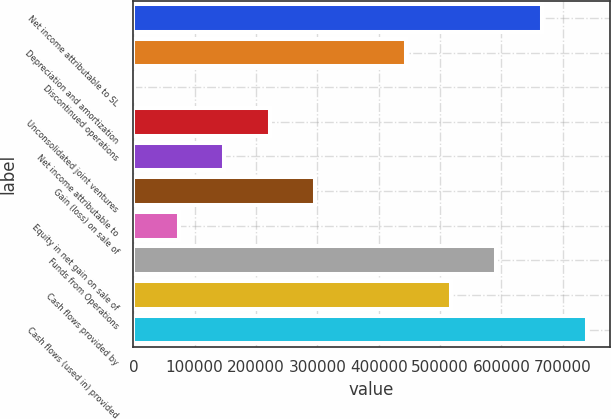Convert chart. <chart><loc_0><loc_0><loc_500><loc_500><bar_chart><fcel>Net income attributable to SL<fcel>Depreciation and amortization<fcel>Discontinued operations<fcel>Unconsolidated joint ventures<fcel>Net income attributable to<fcel>Gain (loss) on sale of<fcel>Equity in net gain on sale of<fcel>Funds from Operations<fcel>Cash flows provided by<fcel>Cash flows (used in) provided<nl><fcel>665705<fcel>444029<fcel>676<fcel>222352<fcel>148460<fcel>296244<fcel>74568.1<fcel>591813<fcel>517921<fcel>739597<nl></chart> 